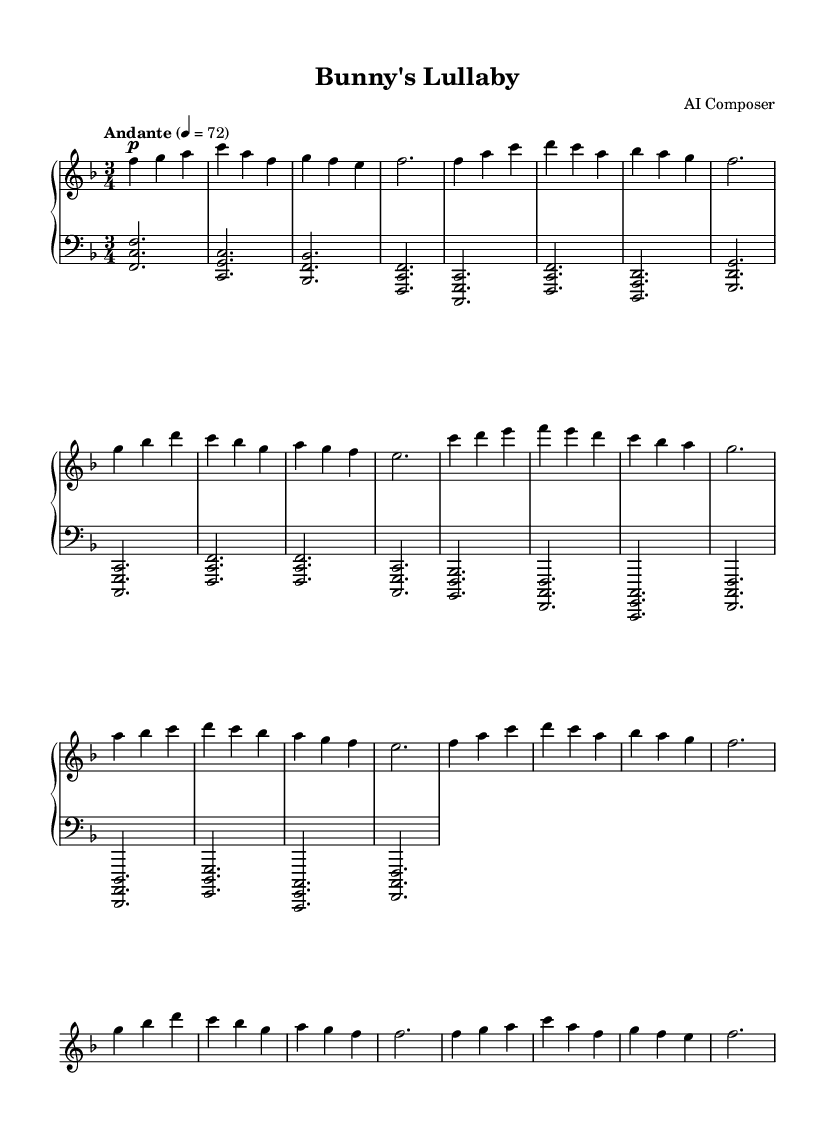What is the key signature of this music? The key signature is indicated at the beginning of the sheet music. In this case, there is one flat, which represents F major or D minor.
Answer: F major What is the time signature of this music? The time signature is found at the beginning of the piece next to the key signature. Here, it shows a 3/4 time signature, meaning there are three beats in each measure and the quarter note receives one beat.
Answer: 3/4 What is the tempo marking for this piece? The tempo marking is provided in the first line of the sheet music and specifies the speed of the piece. It reads "Andante," which indicates a moderate walking pace, along with a metronome marking of 72 beats per minute.
Answer: Andante How many distinct sections are in this piece? The piece appears to have been structured with sections labeled A, B, and a Coda. Observing the repetition and variations, you can see there are three main sections and an ending segment, indicating a structured composition.
Answer: 3 What dynamic markings are used in this music? The dynamics are indicated with markings above the notes. Throughout the piece, the primary dynamic seen is "p" for pianissimo, suggesting it should be played softly. There are no markings indicating louder dynamics in the visible sections.
Answer: p How many notes are in the first measure of the right hand? By examining the first measure of the right hand, the notes F, G, and A are present. Since each note corresponds to a quarter note, it's clear this measure contains three distinct notes.
Answer: 3 What is the last note in the piece? The last measure ends with the note F, which can be traced in the right hand's last bar, indicating this is the concluding note of the composition.
Answer: F 